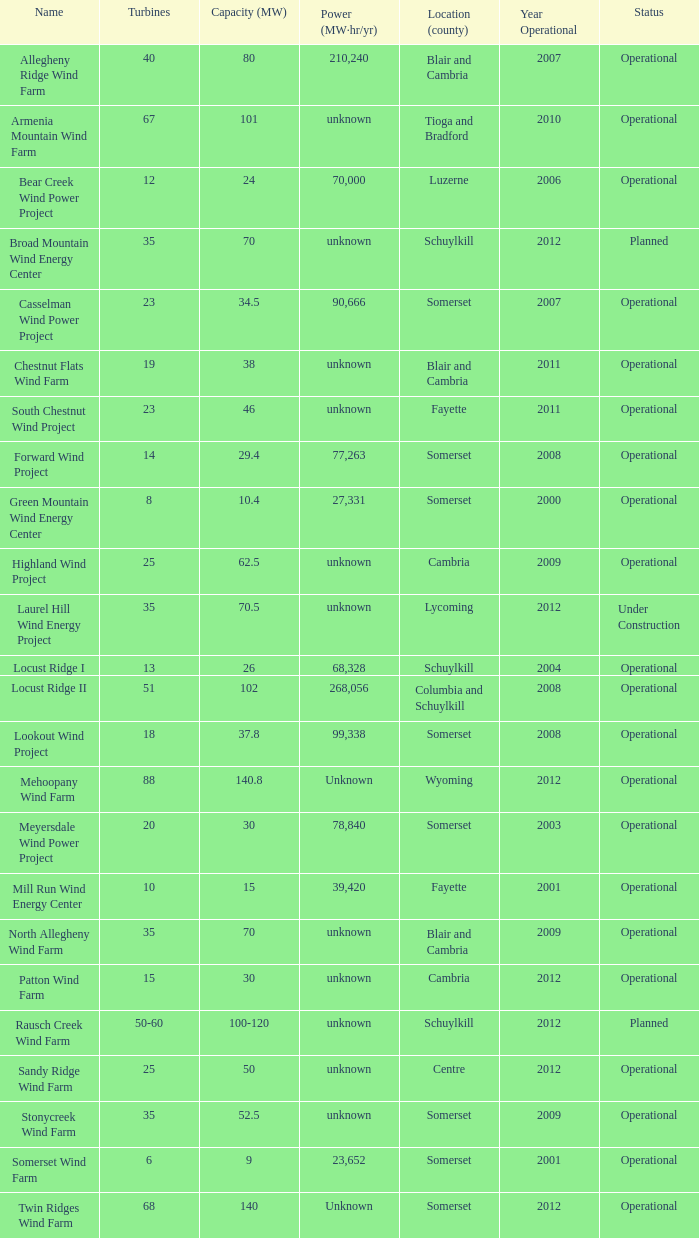What are the diverse capacities for turbines between 50 and 60? 100-120. 